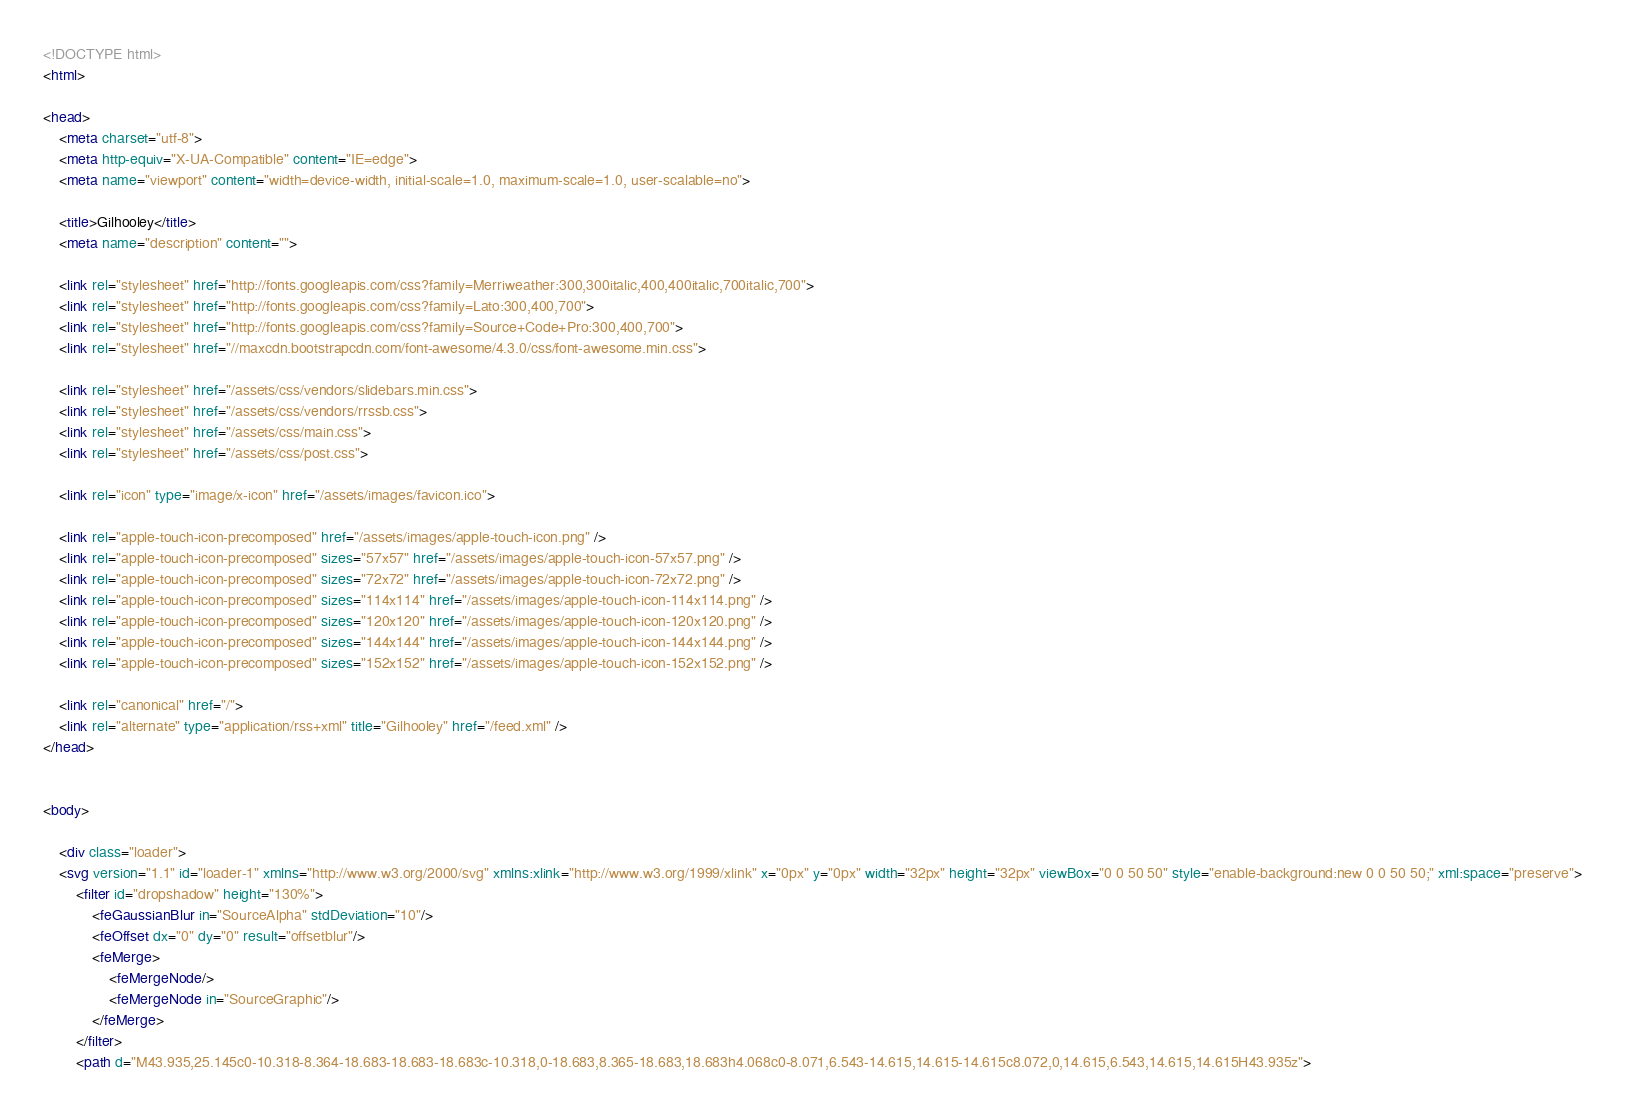Convert code to text. <code><loc_0><loc_0><loc_500><loc_500><_HTML_><!DOCTYPE html>
<html>

<head>
    <meta charset="utf-8">
    <meta http-equiv="X-UA-Compatible" content="IE=edge">
    <meta name="viewport" content="width=device-width, initial-scale=1.0, maximum-scale=1.0, user-scalable=no">

    <title>Gilhooley</title>
    <meta name="description" content="">

    <link rel="stylesheet" href="http://fonts.googleapis.com/css?family=Merriweather:300,300italic,400,400italic,700italic,700">
    <link rel="stylesheet" href="http://fonts.googleapis.com/css?family=Lato:300,400,700">
    <link rel="stylesheet" href="http://fonts.googleapis.com/css?family=Source+Code+Pro:300,400,700">
    <link rel="stylesheet" href="//maxcdn.bootstrapcdn.com/font-awesome/4.3.0/css/font-awesome.min.css">

    <link rel="stylesheet" href="/assets/css/vendors/slidebars.min.css">
    <link rel="stylesheet" href="/assets/css/vendors/rrssb.css">
    <link rel="stylesheet" href="/assets/css/main.css">
    <link rel="stylesheet" href="/assets/css/post.css">

    <link rel="icon" type="image/x-icon" href="/assets/images/favicon.ico">

    <link rel="apple-touch-icon-precomposed" href="/assets/images/apple-touch-icon.png" />
    <link rel="apple-touch-icon-precomposed" sizes="57x57" href="/assets/images/apple-touch-icon-57x57.png" />
    <link rel="apple-touch-icon-precomposed" sizes="72x72" href="/assets/images/apple-touch-icon-72x72.png" />
    <link rel="apple-touch-icon-precomposed" sizes="114x114" href="/assets/images/apple-touch-icon-114x114.png" />
    <link rel="apple-touch-icon-precomposed" sizes="120x120" href="/assets/images/apple-touch-icon-120x120.png" />
    <link rel="apple-touch-icon-precomposed" sizes="144x144" href="/assets/images/apple-touch-icon-144x144.png" />
    <link rel="apple-touch-icon-precomposed" sizes="152x152" href="/assets/images/apple-touch-icon-152x152.png" />

    <link rel="canonical" href="/">
    <link rel="alternate" type="application/rss+xml" title="Gilhooley" href="/feed.xml" />
</head>


<body>

    <div class="loader">
    <svg version="1.1" id="loader-1" xmlns="http://www.w3.org/2000/svg" xmlns:xlink="http://www.w3.org/1999/xlink" x="0px" y="0px" width="32px" height="32px" viewBox="0 0 50 50" style="enable-background:new 0 0 50 50;" xml:space="preserve">
        <filter id="dropshadow" height="130%">
            <feGaussianBlur in="SourceAlpha" stdDeviation="10"/>
            <feOffset dx="0" dy="0" result="offsetblur"/>
            <feMerge>
                <feMergeNode/>
                <feMergeNode in="SourceGraphic"/>
            </feMerge>
        </filter>
        <path d="M43.935,25.145c0-10.318-8.364-18.683-18.683-18.683c-10.318,0-18.683,8.365-18.683,18.683h4.068c0-8.071,6.543-14.615,14.615-14.615c8.072,0,14.615,6.543,14.615,14.615H43.935z"></code> 